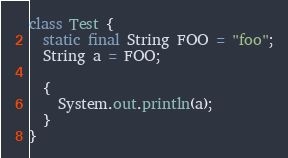Convert code to text. <code><loc_0><loc_0><loc_500><loc_500><_Java_>class Test {
  static final String FOO = "foo";
  String a = FOO;

  {
    System.out.println(a);
  }
}</code> 